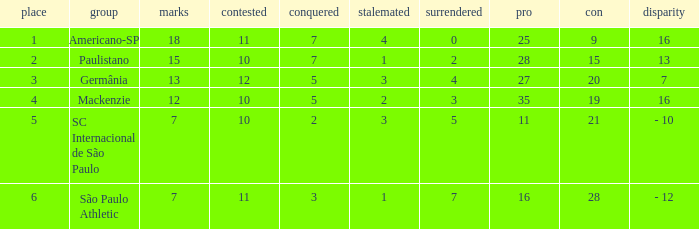Name the points for paulistano 15.0. 